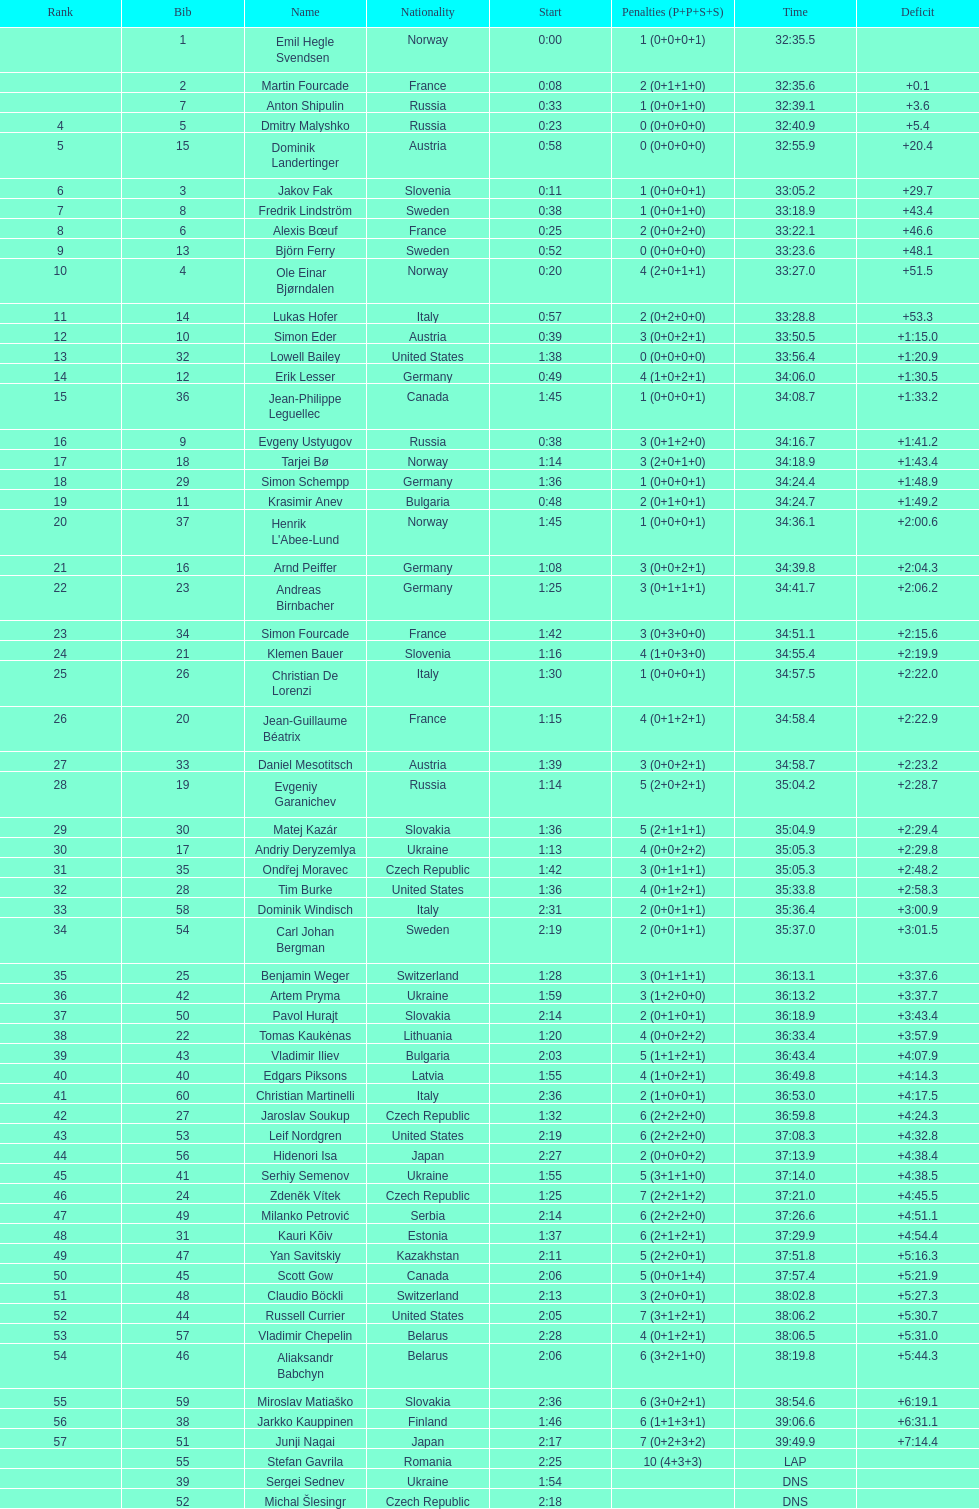How many people completed in a minimum of 35:00? 30. 